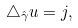Convert formula to latex. <formula><loc_0><loc_0><loc_500><loc_500>\triangle _ { \hat { \gamma } } u = j ,</formula> 